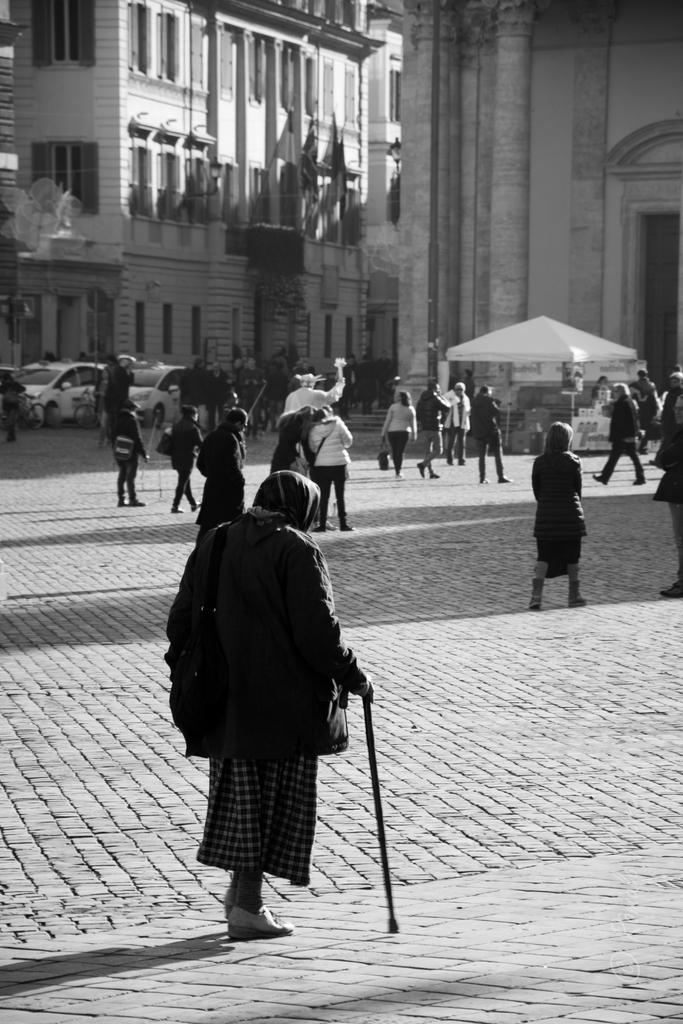Who or what can be seen in the image? There are people in the image. What else is present in the image besides people? There are vehicles, flags, boards, a tent, and buildings in the background of the image. Can you describe the vehicles in the image? The provided facts do not specify the type of vehicles in the image. What is the purpose of the boards in the image? The provided facts do not specify the purpose of the boards in the image. What type of oil is being used for the treatment of the crime scene in the image? There is no mention of oil, treatment, or crime scene in the image. The image features people, vehicles, flags, boards, a tent, and buildings in the background. 